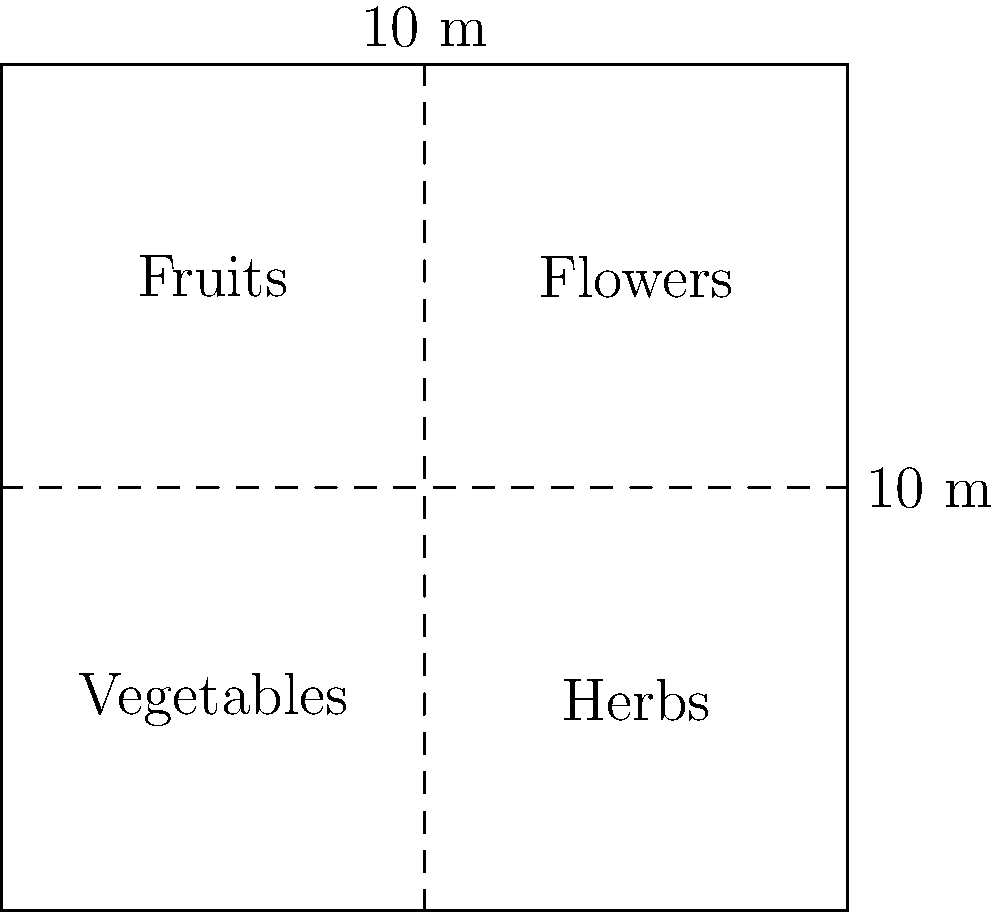An organic gardener wants to create a square garden plot that maximizes the use of space while accommodating four equal sections for vegetables, herbs, fruits, and flowers. If the total area available is 100 square meters, what should be the length of each side of the square garden plot, and what will be the area of each section? To solve this problem, we'll follow these steps:

1. Understand the given information:
   - The garden plot is square-shaped
   - The total area is 100 square meters
   - The plot is divided into four equal sections

2. Calculate the length of each side of the square garden:
   - Area of a square = side length squared
   - $100 \text{ m}^2 = x^2$, where $x$ is the side length
   - $x = \sqrt{100} = 10 \text{ m}$

3. Calculate the area of each section:
   - Total area = 100 $\text{m}^2$
   - Number of sections = 4
   - Area of each section = $100 \text{ m}^2 \div 4 = 25 \text{ m}^2$

Therefore, the length of each side of the square garden plot should be 10 meters, and the area of each section (vegetables, herbs, fruits, and flowers) will be 25 square meters.
Answer: Side length: 10 m; Section area: 25 $\text{m}^2$ 